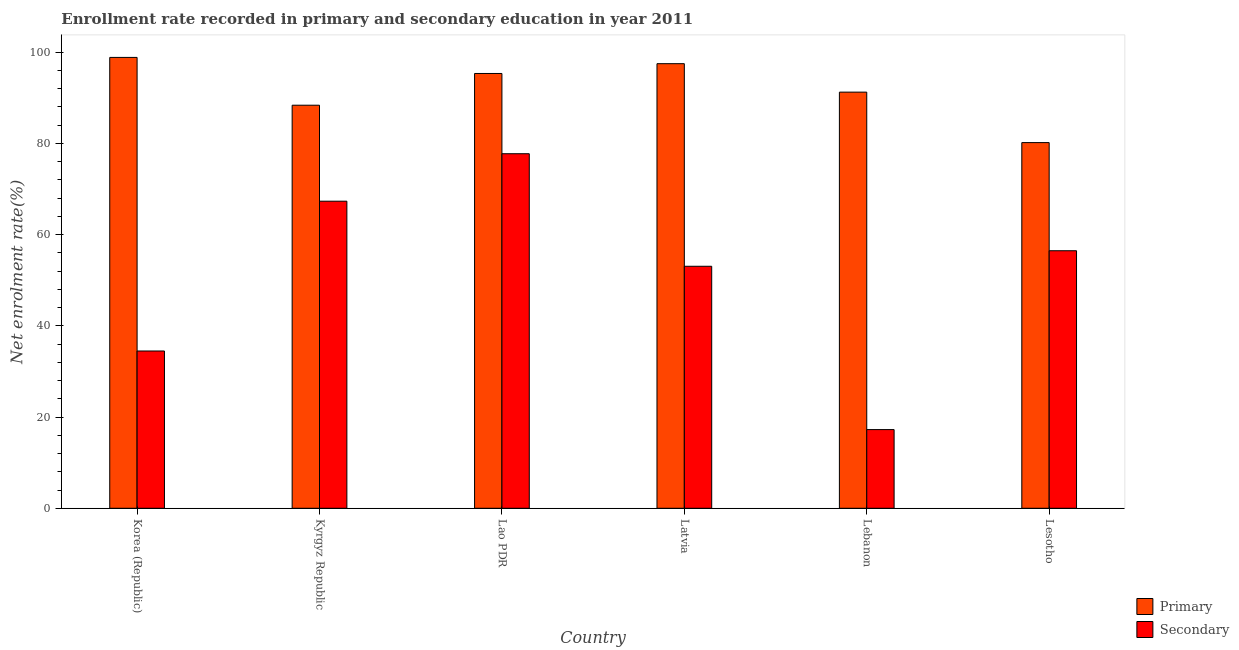How many groups of bars are there?
Provide a short and direct response. 6. What is the label of the 5th group of bars from the left?
Your response must be concise. Lebanon. What is the enrollment rate in secondary education in Korea (Republic)?
Your answer should be compact. 34.49. Across all countries, what is the maximum enrollment rate in secondary education?
Make the answer very short. 77.75. Across all countries, what is the minimum enrollment rate in primary education?
Give a very brief answer. 80.19. In which country was the enrollment rate in primary education maximum?
Give a very brief answer. Korea (Republic). In which country was the enrollment rate in secondary education minimum?
Your answer should be very brief. Lebanon. What is the total enrollment rate in secondary education in the graph?
Provide a short and direct response. 306.37. What is the difference between the enrollment rate in primary education in Lao PDR and that in Latvia?
Offer a very short reply. -2.15. What is the difference between the enrollment rate in secondary education in Lesotho and the enrollment rate in primary education in Latvia?
Your response must be concise. -41.02. What is the average enrollment rate in secondary education per country?
Keep it short and to the point. 51.06. What is the difference between the enrollment rate in primary education and enrollment rate in secondary education in Latvia?
Offer a very short reply. 44.43. In how many countries, is the enrollment rate in secondary education greater than 52 %?
Your answer should be very brief. 4. What is the ratio of the enrollment rate in primary education in Korea (Republic) to that in Kyrgyz Republic?
Your answer should be very brief. 1.12. Is the enrollment rate in secondary education in Kyrgyz Republic less than that in Lesotho?
Give a very brief answer. No. What is the difference between the highest and the second highest enrollment rate in primary education?
Ensure brevity in your answer.  1.37. What is the difference between the highest and the lowest enrollment rate in primary education?
Provide a succinct answer. 18.68. In how many countries, is the enrollment rate in secondary education greater than the average enrollment rate in secondary education taken over all countries?
Keep it short and to the point. 4. Is the sum of the enrollment rate in primary education in Korea (Republic) and Kyrgyz Republic greater than the maximum enrollment rate in secondary education across all countries?
Offer a terse response. Yes. What does the 2nd bar from the left in Lesotho represents?
Your response must be concise. Secondary. What does the 2nd bar from the right in Lebanon represents?
Make the answer very short. Primary. How many countries are there in the graph?
Keep it short and to the point. 6. Does the graph contain any zero values?
Provide a short and direct response. No. Does the graph contain grids?
Provide a succinct answer. No. How are the legend labels stacked?
Ensure brevity in your answer.  Vertical. What is the title of the graph?
Your response must be concise. Enrollment rate recorded in primary and secondary education in year 2011. What is the label or title of the X-axis?
Provide a succinct answer. Country. What is the label or title of the Y-axis?
Offer a terse response. Net enrolment rate(%). What is the Net enrolment rate(%) of Primary in Korea (Republic)?
Your response must be concise. 98.87. What is the Net enrolment rate(%) of Secondary in Korea (Republic)?
Your answer should be compact. 34.49. What is the Net enrolment rate(%) in Primary in Kyrgyz Republic?
Keep it short and to the point. 88.39. What is the Net enrolment rate(%) in Secondary in Kyrgyz Republic?
Provide a short and direct response. 67.34. What is the Net enrolment rate(%) of Primary in Lao PDR?
Your answer should be very brief. 95.35. What is the Net enrolment rate(%) of Secondary in Lao PDR?
Offer a very short reply. 77.75. What is the Net enrolment rate(%) in Primary in Latvia?
Provide a succinct answer. 97.49. What is the Net enrolment rate(%) in Secondary in Latvia?
Offer a very short reply. 53.07. What is the Net enrolment rate(%) of Primary in Lebanon?
Provide a succinct answer. 91.26. What is the Net enrolment rate(%) of Secondary in Lebanon?
Ensure brevity in your answer.  17.25. What is the Net enrolment rate(%) in Primary in Lesotho?
Keep it short and to the point. 80.19. What is the Net enrolment rate(%) in Secondary in Lesotho?
Give a very brief answer. 56.47. Across all countries, what is the maximum Net enrolment rate(%) of Primary?
Give a very brief answer. 98.87. Across all countries, what is the maximum Net enrolment rate(%) in Secondary?
Your answer should be compact. 77.75. Across all countries, what is the minimum Net enrolment rate(%) of Primary?
Provide a short and direct response. 80.19. Across all countries, what is the minimum Net enrolment rate(%) of Secondary?
Your response must be concise. 17.25. What is the total Net enrolment rate(%) in Primary in the graph?
Provide a short and direct response. 551.54. What is the total Net enrolment rate(%) of Secondary in the graph?
Provide a succinct answer. 306.37. What is the difference between the Net enrolment rate(%) in Primary in Korea (Republic) and that in Kyrgyz Republic?
Your answer should be very brief. 10.48. What is the difference between the Net enrolment rate(%) in Secondary in Korea (Republic) and that in Kyrgyz Republic?
Ensure brevity in your answer.  -32.85. What is the difference between the Net enrolment rate(%) of Primary in Korea (Republic) and that in Lao PDR?
Offer a terse response. 3.52. What is the difference between the Net enrolment rate(%) in Secondary in Korea (Republic) and that in Lao PDR?
Offer a terse response. -43.26. What is the difference between the Net enrolment rate(%) of Primary in Korea (Republic) and that in Latvia?
Offer a very short reply. 1.37. What is the difference between the Net enrolment rate(%) in Secondary in Korea (Republic) and that in Latvia?
Your answer should be very brief. -18.58. What is the difference between the Net enrolment rate(%) of Primary in Korea (Republic) and that in Lebanon?
Provide a succinct answer. 7.61. What is the difference between the Net enrolment rate(%) in Secondary in Korea (Republic) and that in Lebanon?
Make the answer very short. 17.24. What is the difference between the Net enrolment rate(%) in Primary in Korea (Republic) and that in Lesotho?
Your answer should be compact. 18.68. What is the difference between the Net enrolment rate(%) in Secondary in Korea (Republic) and that in Lesotho?
Keep it short and to the point. -21.98. What is the difference between the Net enrolment rate(%) of Primary in Kyrgyz Republic and that in Lao PDR?
Your response must be concise. -6.96. What is the difference between the Net enrolment rate(%) in Secondary in Kyrgyz Republic and that in Lao PDR?
Provide a succinct answer. -10.41. What is the difference between the Net enrolment rate(%) in Primary in Kyrgyz Republic and that in Latvia?
Your response must be concise. -9.11. What is the difference between the Net enrolment rate(%) of Secondary in Kyrgyz Republic and that in Latvia?
Ensure brevity in your answer.  14.27. What is the difference between the Net enrolment rate(%) in Primary in Kyrgyz Republic and that in Lebanon?
Offer a very short reply. -2.87. What is the difference between the Net enrolment rate(%) of Secondary in Kyrgyz Republic and that in Lebanon?
Your response must be concise. 50.09. What is the difference between the Net enrolment rate(%) of Primary in Kyrgyz Republic and that in Lesotho?
Offer a terse response. 8.2. What is the difference between the Net enrolment rate(%) in Secondary in Kyrgyz Republic and that in Lesotho?
Ensure brevity in your answer.  10.87. What is the difference between the Net enrolment rate(%) in Primary in Lao PDR and that in Latvia?
Your answer should be very brief. -2.15. What is the difference between the Net enrolment rate(%) of Secondary in Lao PDR and that in Latvia?
Make the answer very short. 24.68. What is the difference between the Net enrolment rate(%) in Primary in Lao PDR and that in Lebanon?
Your answer should be very brief. 4.09. What is the difference between the Net enrolment rate(%) of Secondary in Lao PDR and that in Lebanon?
Offer a very short reply. 60.5. What is the difference between the Net enrolment rate(%) of Primary in Lao PDR and that in Lesotho?
Your answer should be compact. 15.16. What is the difference between the Net enrolment rate(%) of Secondary in Lao PDR and that in Lesotho?
Provide a succinct answer. 21.28. What is the difference between the Net enrolment rate(%) of Primary in Latvia and that in Lebanon?
Your response must be concise. 6.24. What is the difference between the Net enrolment rate(%) in Secondary in Latvia and that in Lebanon?
Provide a succinct answer. 35.81. What is the difference between the Net enrolment rate(%) of Primary in Latvia and that in Lesotho?
Offer a terse response. 17.31. What is the difference between the Net enrolment rate(%) of Secondary in Latvia and that in Lesotho?
Keep it short and to the point. -3.41. What is the difference between the Net enrolment rate(%) of Primary in Lebanon and that in Lesotho?
Provide a succinct answer. 11.07. What is the difference between the Net enrolment rate(%) of Secondary in Lebanon and that in Lesotho?
Offer a very short reply. -39.22. What is the difference between the Net enrolment rate(%) of Primary in Korea (Republic) and the Net enrolment rate(%) of Secondary in Kyrgyz Republic?
Make the answer very short. 31.53. What is the difference between the Net enrolment rate(%) in Primary in Korea (Republic) and the Net enrolment rate(%) in Secondary in Lao PDR?
Offer a very short reply. 21.12. What is the difference between the Net enrolment rate(%) of Primary in Korea (Republic) and the Net enrolment rate(%) of Secondary in Latvia?
Your answer should be very brief. 45.8. What is the difference between the Net enrolment rate(%) of Primary in Korea (Republic) and the Net enrolment rate(%) of Secondary in Lebanon?
Keep it short and to the point. 81.61. What is the difference between the Net enrolment rate(%) of Primary in Korea (Republic) and the Net enrolment rate(%) of Secondary in Lesotho?
Ensure brevity in your answer.  42.4. What is the difference between the Net enrolment rate(%) of Primary in Kyrgyz Republic and the Net enrolment rate(%) of Secondary in Lao PDR?
Offer a very short reply. 10.64. What is the difference between the Net enrolment rate(%) in Primary in Kyrgyz Republic and the Net enrolment rate(%) in Secondary in Latvia?
Give a very brief answer. 35.32. What is the difference between the Net enrolment rate(%) in Primary in Kyrgyz Republic and the Net enrolment rate(%) in Secondary in Lebanon?
Your response must be concise. 71.13. What is the difference between the Net enrolment rate(%) in Primary in Kyrgyz Republic and the Net enrolment rate(%) in Secondary in Lesotho?
Make the answer very short. 31.92. What is the difference between the Net enrolment rate(%) in Primary in Lao PDR and the Net enrolment rate(%) in Secondary in Latvia?
Give a very brief answer. 42.28. What is the difference between the Net enrolment rate(%) in Primary in Lao PDR and the Net enrolment rate(%) in Secondary in Lebanon?
Offer a terse response. 78.09. What is the difference between the Net enrolment rate(%) of Primary in Lao PDR and the Net enrolment rate(%) of Secondary in Lesotho?
Offer a terse response. 38.87. What is the difference between the Net enrolment rate(%) in Primary in Latvia and the Net enrolment rate(%) in Secondary in Lebanon?
Keep it short and to the point. 80.24. What is the difference between the Net enrolment rate(%) in Primary in Latvia and the Net enrolment rate(%) in Secondary in Lesotho?
Offer a terse response. 41.02. What is the difference between the Net enrolment rate(%) in Primary in Lebanon and the Net enrolment rate(%) in Secondary in Lesotho?
Give a very brief answer. 34.78. What is the average Net enrolment rate(%) of Primary per country?
Provide a succinct answer. 91.92. What is the average Net enrolment rate(%) of Secondary per country?
Offer a terse response. 51.06. What is the difference between the Net enrolment rate(%) in Primary and Net enrolment rate(%) in Secondary in Korea (Republic)?
Make the answer very short. 64.38. What is the difference between the Net enrolment rate(%) in Primary and Net enrolment rate(%) in Secondary in Kyrgyz Republic?
Your response must be concise. 21.05. What is the difference between the Net enrolment rate(%) in Primary and Net enrolment rate(%) in Secondary in Lao PDR?
Offer a very short reply. 17.6. What is the difference between the Net enrolment rate(%) of Primary and Net enrolment rate(%) of Secondary in Latvia?
Provide a succinct answer. 44.43. What is the difference between the Net enrolment rate(%) of Primary and Net enrolment rate(%) of Secondary in Lebanon?
Keep it short and to the point. 74. What is the difference between the Net enrolment rate(%) in Primary and Net enrolment rate(%) in Secondary in Lesotho?
Your response must be concise. 23.71. What is the ratio of the Net enrolment rate(%) in Primary in Korea (Republic) to that in Kyrgyz Republic?
Keep it short and to the point. 1.12. What is the ratio of the Net enrolment rate(%) in Secondary in Korea (Republic) to that in Kyrgyz Republic?
Your answer should be compact. 0.51. What is the ratio of the Net enrolment rate(%) in Primary in Korea (Republic) to that in Lao PDR?
Provide a short and direct response. 1.04. What is the ratio of the Net enrolment rate(%) in Secondary in Korea (Republic) to that in Lao PDR?
Keep it short and to the point. 0.44. What is the ratio of the Net enrolment rate(%) of Primary in Korea (Republic) to that in Latvia?
Give a very brief answer. 1.01. What is the ratio of the Net enrolment rate(%) in Secondary in Korea (Republic) to that in Latvia?
Provide a succinct answer. 0.65. What is the ratio of the Net enrolment rate(%) in Primary in Korea (Republic) to that in Lebanon?
Your answer should be compact. 1.08. What is the ratio of the Net enrolment rate(%) of Secondary in Korea (Republic) to that in Lebanon?
Ensure brevity in your answer.  2. What is the ratio of the Net enrolment rate(%) of Primary in Korea (Republic) to that in Lesotho?
Offer a very short reply. 1.23. What is the ratio of the Net enrolment rate(%) of Secondary in Korea (Republic) to that in Lesotho?
Your answer should be very brief. 0.61. What is the ratio of the Net enrolment rate(%) in Primary in Kyrgyz Republic to that in Lao PDR?
Make the answer very short. 0.93. What is the ratio of the Net enrolment rate(%) in Secondary in Kyrgyz Republic to that in Lao PDR?
Offer a terse response. 0.87. What is the ratio of the Net enrolment rate(%) of Primary in Kyrgyz Republic to that in Latvia?
Your answer should be very brief. 0.91. What is the ratio of the Net enrolment rate(%) in Secondary in Kyrgyz Republic to that in Latvia?
Your answer should be very brief. 1.27. What is the ratio of the Net enrolment rate(%) in Primary in Kyrgyz Republic to that in Lebanon?
Your answer should be compact. 0.97. What is the ratio of the Net enrolment rate(%) in Secondary in Kyrgyz Republic to that in Lebanon?
Your response must be concise. 3.9. What is the ratio of the Net enrolment rate(%) of Primary in Kyrgyz Republic to that in Lesotho?
Provide a succinct answer. 1.1. What is the ratio of the Net enrolment rate(%) in Secondary in Kyrgyz Republic to that in Lesotho?
Provide a short and direct response. 1.19. What is the ratio of the Net enrolment rate(%) of Secondary in Lao PDR to that in Latvia?
Make the answer very short. 1.47. What is the ratio of the Net enrolment rate(%) in Primary in Lao PDR to that in Lebanon?
Ensure brevity in your answer.  1.04. What is the ratio of the Net enrolment rate(%) in Secondary in Lao PDR to that in Lebanon?
Make the answer very short. 4.51. What is the ratio of the Net enrolment rate(%) in Primary in Lao PDR to that in Lesotho?
Ensure brevity in your answer.  1.19. What is the ratio of the Net enrolment rate(%) of Secondary in Lao PDR to that in Lesotho?
Ensure brevity in your answer.  1.38. What is the ratio of the Net enrolment rate(%) of Primary in Latvia to that in Lebanon?
Your answer should be compact. 1.07. What is the ratio of the Net enrolment rate(%) of Secondary in Latvia to that in Lebanon?
Provide a short and direct response. 3.08. What is the ratio of the Net enrolment rate(%) of Primary in Latvia to that in Lesotho?
Keep it short and to the point. 1.22. What is the ratio of the Net enrolment rate(%) of Secondary in Latvia to that in Lesotho?
Your answer should be very brief. 0.94. What is the ratio of the Net enrolment rate(%) in Primary in Lebanon to that in Lesotho?
Your answer should be very brief. 1.14. What is the ratio of the Net enrolment rate(%) in Secondary in Lebanon to that in Lesotho?
Provide a short and direct response. 0.31. What is the difference between the highest and the second highest Net enrolment rate(%) in Primary?
Your response must be concise. 1.37. What is the difference between the highest and the second highest Net enrolment rate(%) in Secondary?
Ensure brevity in your answer.  10.41. What is the difference between the highest and the lowest Net enrolment rate(%) of Primary?
Your answer should be compact. 18.68. What is the difference between the highest and the lowest Net enrolment rate(%) of Secondary?
Ensure brevity in your answer.  60.5. 